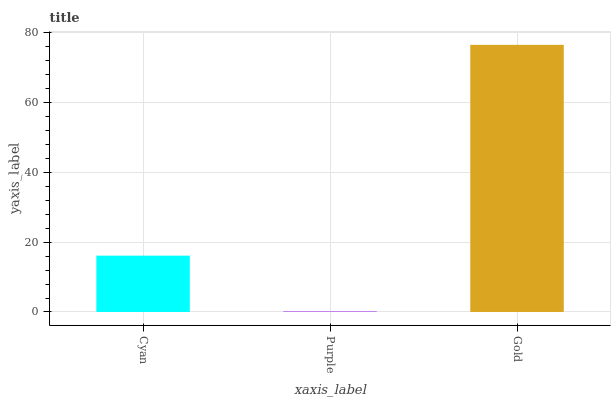Is Purple the minimum?
Answer yes or no. Yes. Is Gold the maximum?
Answer yes or no. Yes. Is Gold the minimum?
Answer yes or no. No. Is Purple the maximum?
Answer yes or no. No. Is Gold greater than Purple?
Answer yes or no. Yes. Is Purple less than Gold?
Answer yes or no. Yes. Is Purple greater than Gold?
Answer yes or no. No. Is Gold less than Purple?
Answer yes or no. No. Is Cyan the high median?
Answer yes or no. Yes. Is Cyan the low median?
Answer yes or no. Yes. Is Purple the high median?
Answer yes or no. No. Is Gold the low median?
Answer yes or no. No. 